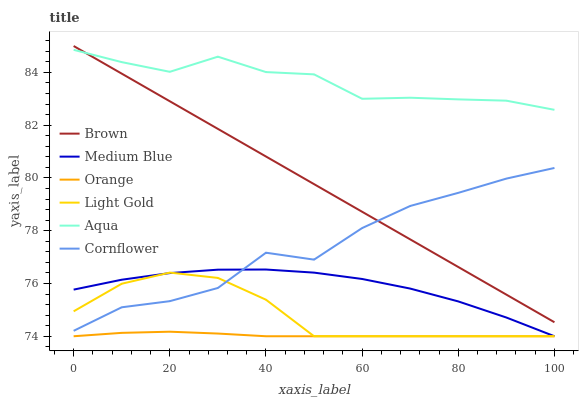Does Orange have the minimum area under the curve?
Answer yes or no. Yes. Does Aqua have the maximum area under the curve?
Answer yes or no. Yes. Does Cornflower have the minimum area under the curve?
Answer yes or no. No. Does Cornflower have the maximum area under the curve?
Answer yes or no. No. Is Brown the smoothest?
Answer yes or no. Yes. Is Cornflower the roughest?
Answer yes or no. Yes. Is Medium Blue the smoothest?
Answer yes or no. No. Is Medium Blue the roughest?
Answer yes or no. No. Does Medium Blue have the lowest value?
Answer yes or no. Yes. Does Cornflower have the lowest value?
Answer yes or no. No. Does Brown have the highest value?
Answer yes or no. Yes. Does Cornflower have the highest value?
Answer yes or no. No. Is Cornflower less than Aqua?
Answer yes or no. Yes. Is Brown greater than Light Gold?
Answer yes or no. Yes. Does Orange intersect Light Gold?
Answer yes or no. Yes. Is Orange less than Light Gold?
Answer yes or no. No. Is Orange greater than Light Gold?
Answer yes or no. No. Does Cornflower intersect Aqua?
Answer yes or no. No. 